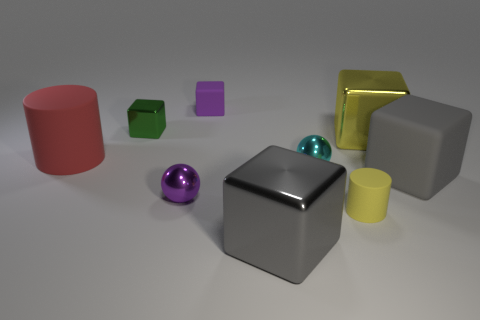Is there any other thing that has the same color as the tiny metal block?
Provide a succinct answer. No. Is the cyan ball the same size as the green metallic object?
Ensure brevity in your answer.  Yes. What size is the rubber object that is both behind the cyan object and in front of the purple block?
Your answer should be compact. Large. What number of small purple blocks have the same material as the green thing?
Your answer should be compact. 0. What shape is the big object that is the same color as the small rubber cylinder?
Provide a succinct answer. Cube. What color is the small metal block?
Give a very brief answer. Green. Do the big matte object right of the cyan sphere and the big red thing have the same shape?
Ensure brevity in your answer.  No. What number of objects are either objects that are left of the big gray matte cube or small matte objects?
Your answer should be very brief. 8. Is there another small shiny thing that has the same shape as the tiny purple metal object?
Provide a succinct answer. Yes. What is the shape of the red thing that is the same size as the yellow metallic thing?
Your answer should be compact. Cylinder. 